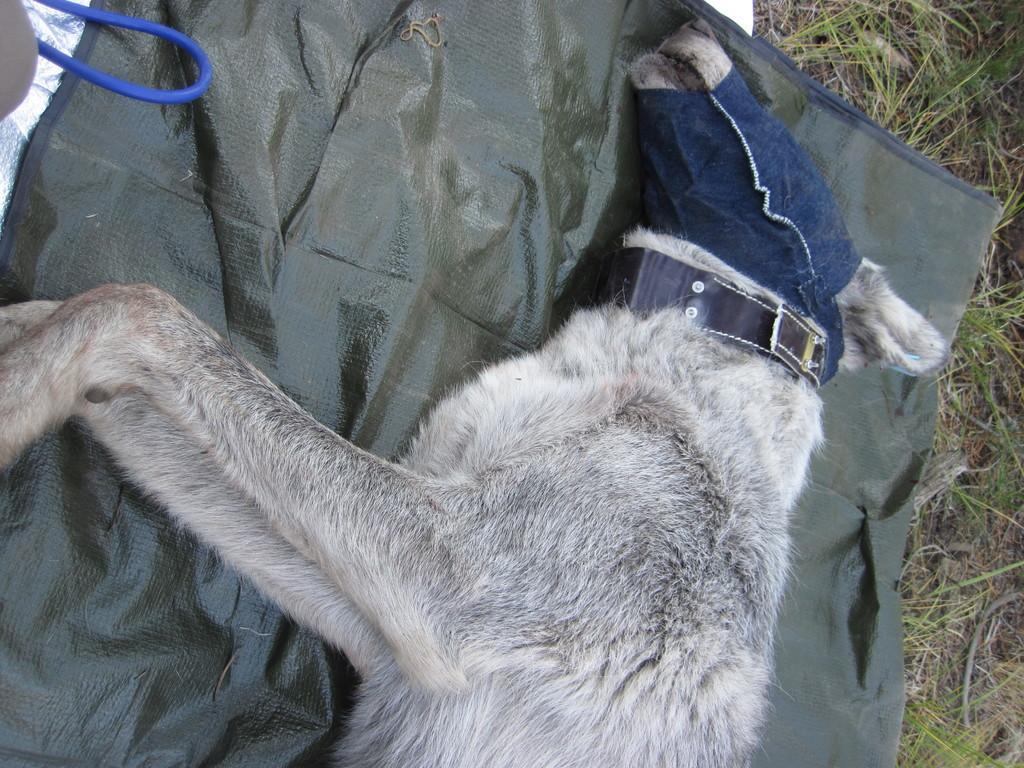Could you give a brief overview of what you see in this image? In this image I can see a dog which is white and black in color is lying on the green colored sheet. I can see some grass on the ground and a blue colored wire. 